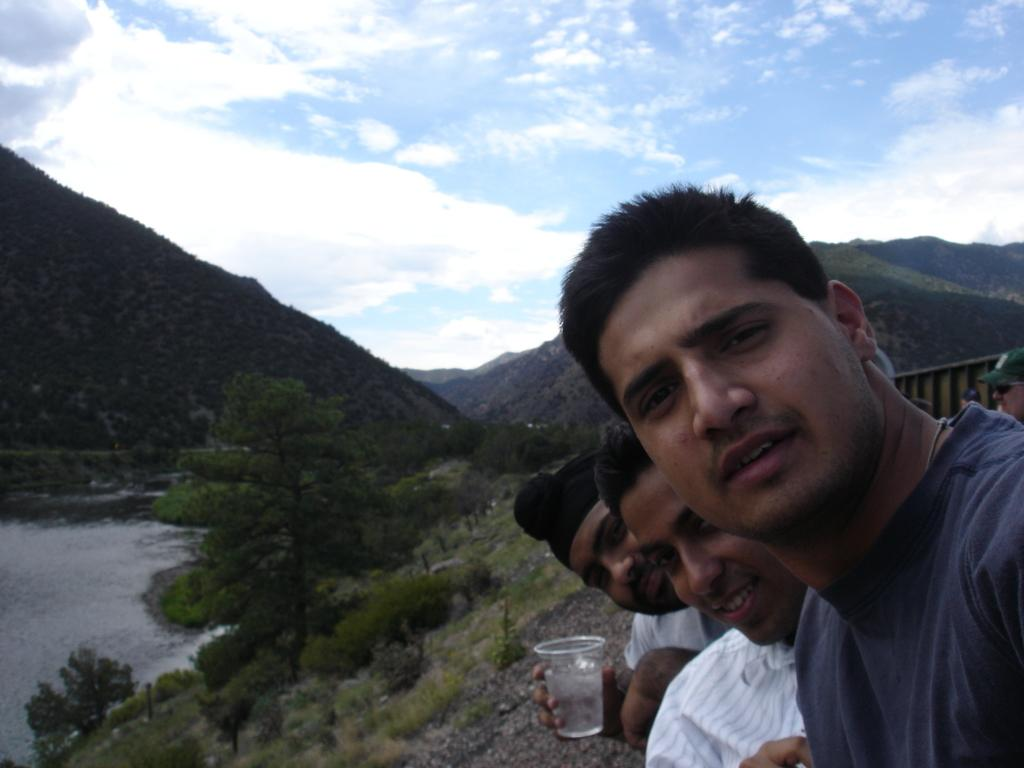How many people are in the image? There is a group of people in the image, but the exact number is not specified. What is one person holding in the image? One person is holding a glass in the image. What can be seen in the background of the image? In the background of the image, there is an object, water, trees, mountains, and the sky. What type of natural landscape is visible in the background of the image? The background of the image features a combination of water, trees, mountains, and the sky, which suggests a natural landscape. Where is the nearest store to the pencil in the image? There is no pencil present in the image, so it is not possible to determine the location of the nearest store. 